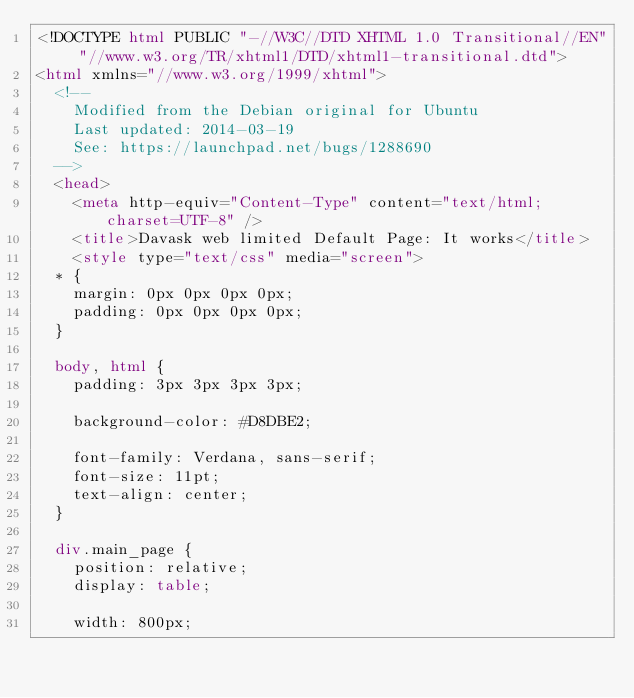Convert code to text. <code><loc_0><loc_0><loc_500><loc_500><_HTML_><!DOCTYPE html PUBLIC "-//W3C//DTD XHTML 1.0 Transitional//EN" "//www.w3.org/TR/xhtml1/DTD/xhtml1-transitional.dtd">
<html xmlns="//www.w3.org/1999/xhtml">
  <!--
    Modified from the Debian original for Ubuntu
    Last updated: 2014-03-19
    See: https://launchpad.net/bugs/1288690
  -->
  <head>
    <meta http-equiv="Content-Type" content="text/html; charset=UTF-8" />
    <title>Davask web limited Default Page: It works</title>
    <style type="text/css" media="screen">
  * {
    margin: 0px 0px 0px 0px;
    padding: 0px 0px 0px 0px;
  }

  body, html {
    padding: 3px 3px 3px 3px;

    background-color: #D8DBE2;

    font-family: Verdana, sans-serif;
    font-size: 11pt;
    text-align: center;
  }

  div.main_page {
    position: relative;
    display: table;

    width: 800px;
</code> 